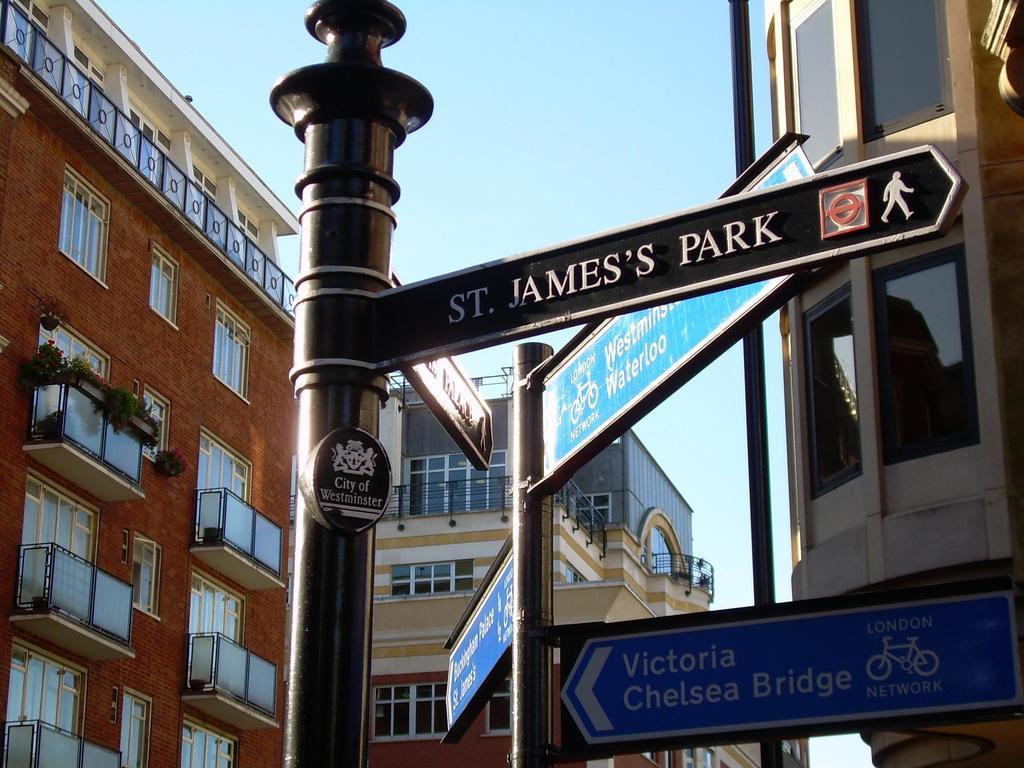Can you describe this image briefly? In the foreground of the picture I can see the name sign board poles. In the background, I can see the buildings and glass windows. There are clouds in the sky. 